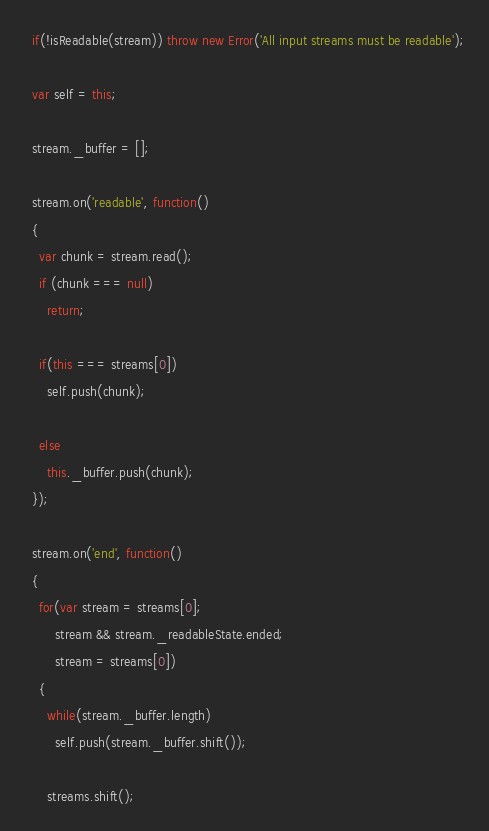Convert code to text. <code><loc_0><loc_0><loc_500><loc_500><_JavaScript_>  if(!isReadable(stream)) throw new Error('All input streams must be readable');

  var self = this;

  stream._buffer = [];

  stream.on('readable', function()
  {
    var chunk = stream.read();
    if (chunk === null)
      return;

    if(this === streams[0])
      self.push(chunk);

    else
      this._buffer.push(chunk);
  });

  stream.on('end', function()
  {
    for(var stream = streams[0];
        stream && stream._readableState.ended;
        stream = streams[0])
    {
      while(stream._buffer.length)
        self.push(stream._buffer.shift());

      streams.shift();</code> 